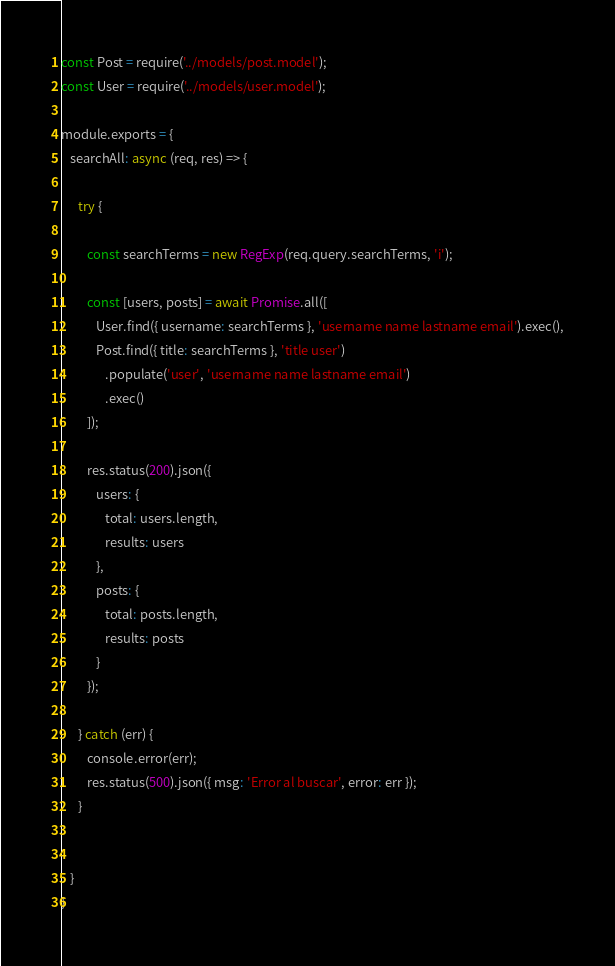<code> <loc_0><loc_0><loc_500><loc_500><_JavaScript_>const Post = require('../models/post.model');
const User = require('../models/user.model');

module.exports = {
   searchAll: async (req, res) => {

      try {

         const searchTerms = new RegExp(req.query.searchTerms, 'i');

         const [users, posts] = await Promise.all([
            User.find({ username: searchTerms }, 'username name lastname email').exec(),
            Post.find({ title: searchTerms }, 'title user')
               .populate('user', 'username name lastname email')
               .exec()
         ]);

         res.status(200).json({
            users: {
               total: users.length,
               results: users
            },
            posts: {
               total: posts.length,
               results: posts
            }
         });

      } catch (err) {
         console.error(err);
         res.status(500).json({ msg: 'Error al buscar', error: err });
      }


   }
}</code> 